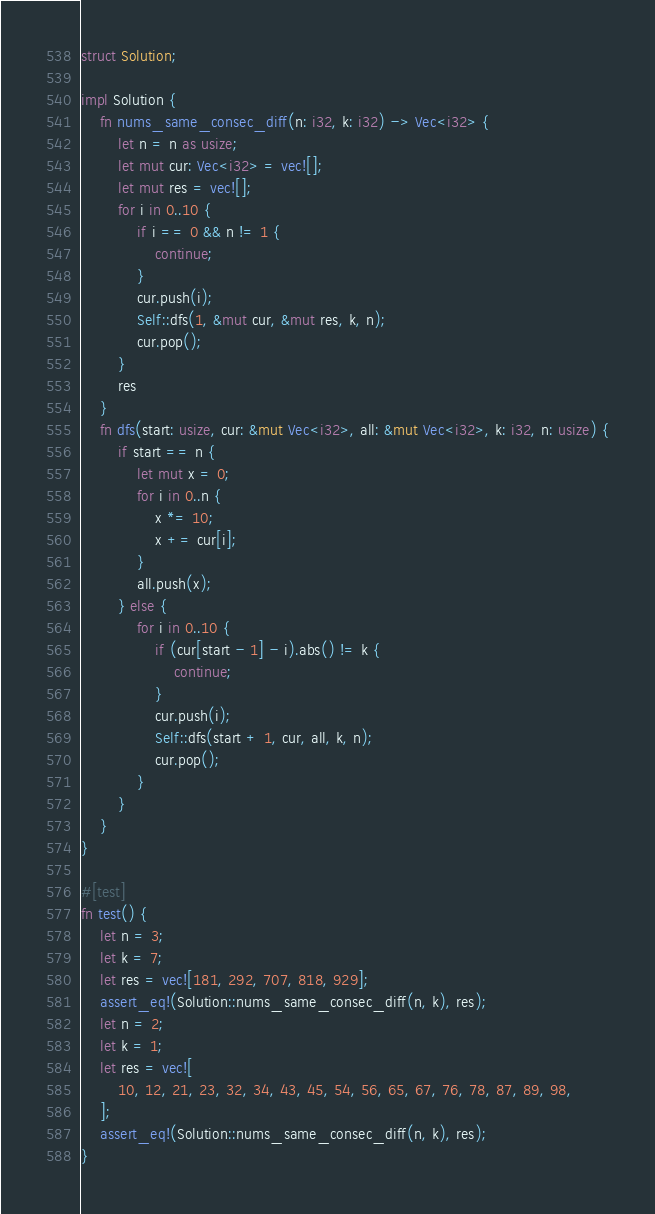Convert code to text. <code><loc_0><loc_0><loc_500><loc_500><_Rust_>struct Solution;

impl Solution {
    fn nums_same_consec_diff(n: i32, k: i32) -> Vec<i32> {
        let n = n as usize;
        let mut cur: Vec<i32> = vec![];
        let mut res = vec![];
        for i in 0..10 {
            if i == 0 && n != 1 {
                continue;
            }
            cur.push(i);
            Self::dfs(1, &mut cur, &mut res, k, n);
            cur.pop();
        }
        res
    }
    fn dfs(start: usize, cur: &mut Vec<i32>, all: &mut Vec<i32>, k: i32, n: usize) {
        if start == n {
            let mut x = 0;
            for i in 0..n {
                x *= 10;
                x += cur[i];
            }
            all.push(x);
        } else {
            for i in 0..10 {
                if (cur[start - 1] - i).abs() != k {
                    continue;
                }
                cur.push(i);
                Self::dfs(start + 1, cur, all, k, n);
                cur.pop();
            }
        }
    }
}

#[test]
fn test() {
    let n = 3;
    let k = 7;
    let res = vec![181, 292, 707, 818, 929];
    assert_eq!(Solution::nums_same_consec_diff(n, k), res);
    let n = 2;
    let k = 1;
    let res = vec![
        10, 12, 21, 23, 32, 34, 43, 45, 54, 56, 65, 67, 76, 78, 87, 89, 98,
    ];
    assert_eq!(Solution::nums_same_consec_diff(n, k), res);
}
</code> 